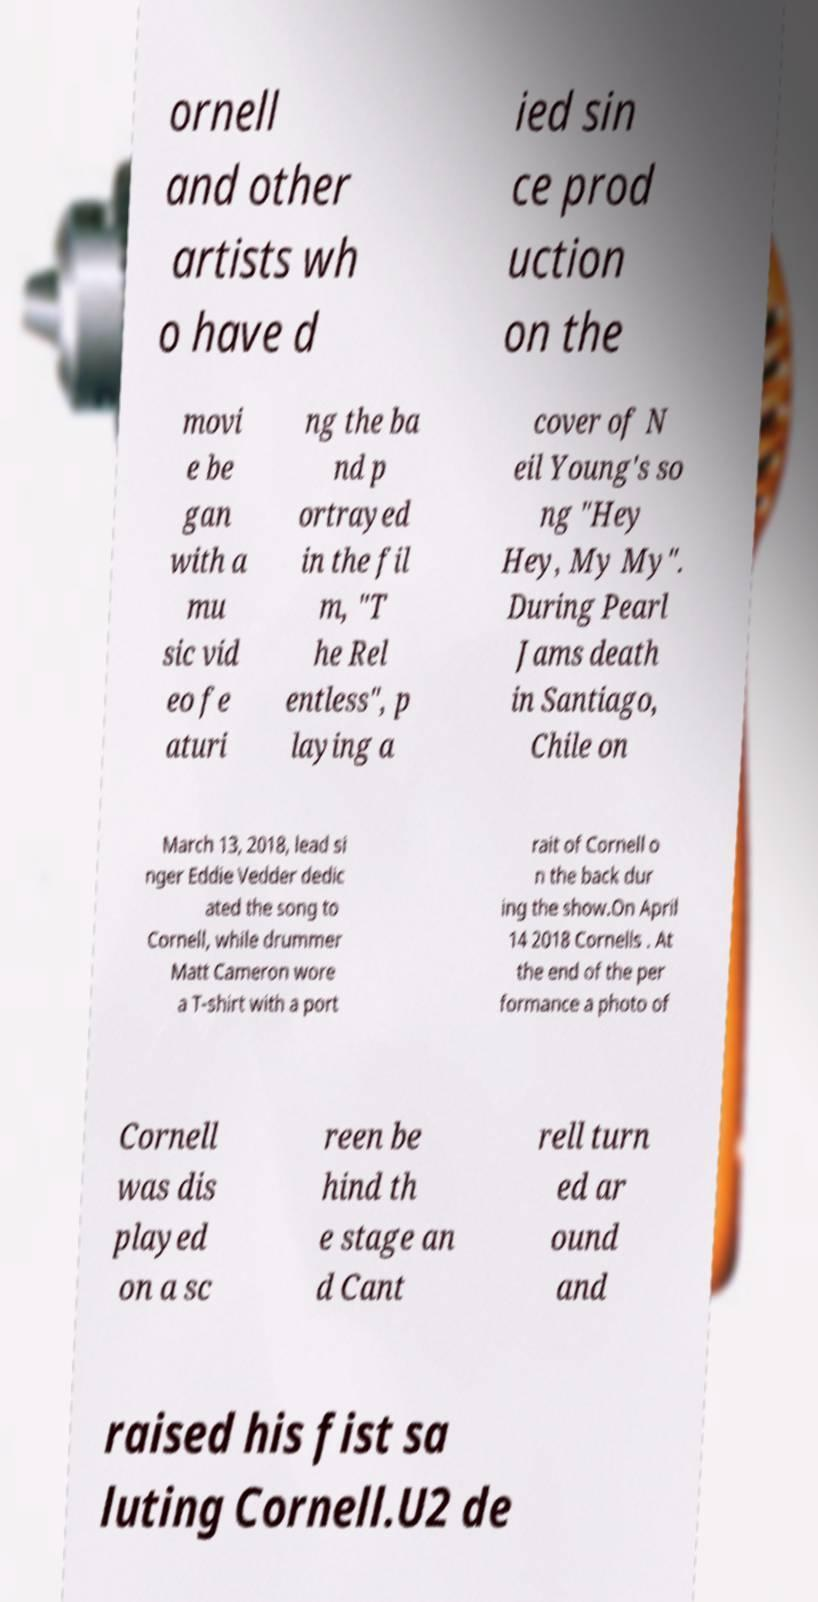For documentation purposes, I need the text within this image transcribed. Could you provide that? ornell and other artists wh o have d ied sin ce prod uction on the movi e be gan with a mu sic vid eo fe aturi ng the ba nd p ortrayed in the fil m, "T he Rel entless", p laying a cover of N eil Young's so ng "Hey Hey, My My". During Pearl Jams death in Santiago, Chile on March 13, 2018, lead si nger Eddie Vedder dedic ated the song to Cornell, while drummer Matt Cameron wore a T-shirt with a port rait of Cornell o n the back dur ing the show.On April 14 2018 Cornells . At the end of the per formance a photo of Cornell was dis played on a sc reen be hind th e stage an d Cant rell turn ed ar ound and raised his fist sa luting Cornell.U2 de 